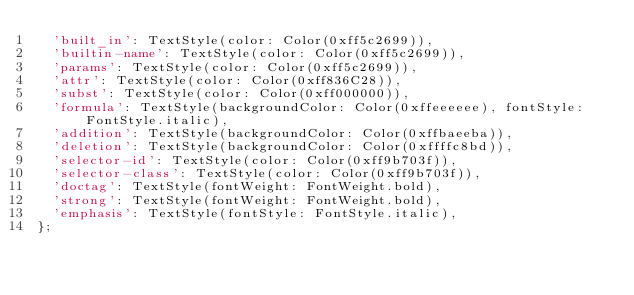Convert code to text. <code><loc_0><loc_0><loc_500><loc_500><_Dart_>  'built_in': TextStyle(color: Color(0xff5c2699)),
  'builtin-name': TextStyle(color: Color(0xff5c2699)),
  'params': TextStyle(color: Color(0xff5c2699)),
  'attr': TextStyle(color: Color(0xff836C28)),
  'subst': TextStyle(color: Color(0xff000000)),
  'formula': TextStyle(backgroundColor: Color(0xffeeeeee), fontStyle: FontStyle.italic),
  'addition': TextStyle(backgroundColor: Color(0xffbaeeba)),
  'deletion': TextStyle(backgroundColor: Color(0xffffc8bd)),
  'selector-id': TextStyle(color: Color(0xff9b703f)),
  'selector-class': TextStyle(color: Color(0xff9b703f)),
  'doctag': TextStyle(fontWeight: FontWeight.bold),
  'strong': TextStyle(fontWeight: FontWeight.bold),
  'emphasis': TextStyle(fontStyle: FontStyle.italic),
};
</code> 